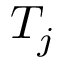Convert formula to latex. <formula><loc_0><loc_0><loc_500><loc_500>T _ { j }</formula> 